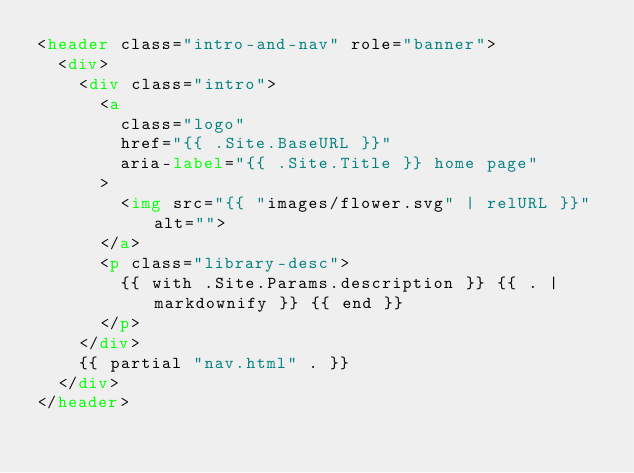Convert code to text. <code><loc_0><loc_0><loc_500><loc_500><_HTML_><header class="intro-and-nav" role="banner">
  <div>
    <div class="intro">
      <a
        class="logo"
        href="{{ .Site.BaseURL }}"
        aria-label="{{ .Site.Title }} home page"
      >
        <img src="{{ "images/flower.svg" | relURL }}" alt="">
      </a>
      <p class="library-desc">
        {{ with .Site.Params.description }} {{ . | markdownify }} {{ end }}
      </p>
    </div>
    {{ partial "nav.html" . }}
  </div>
</header>
</code> 